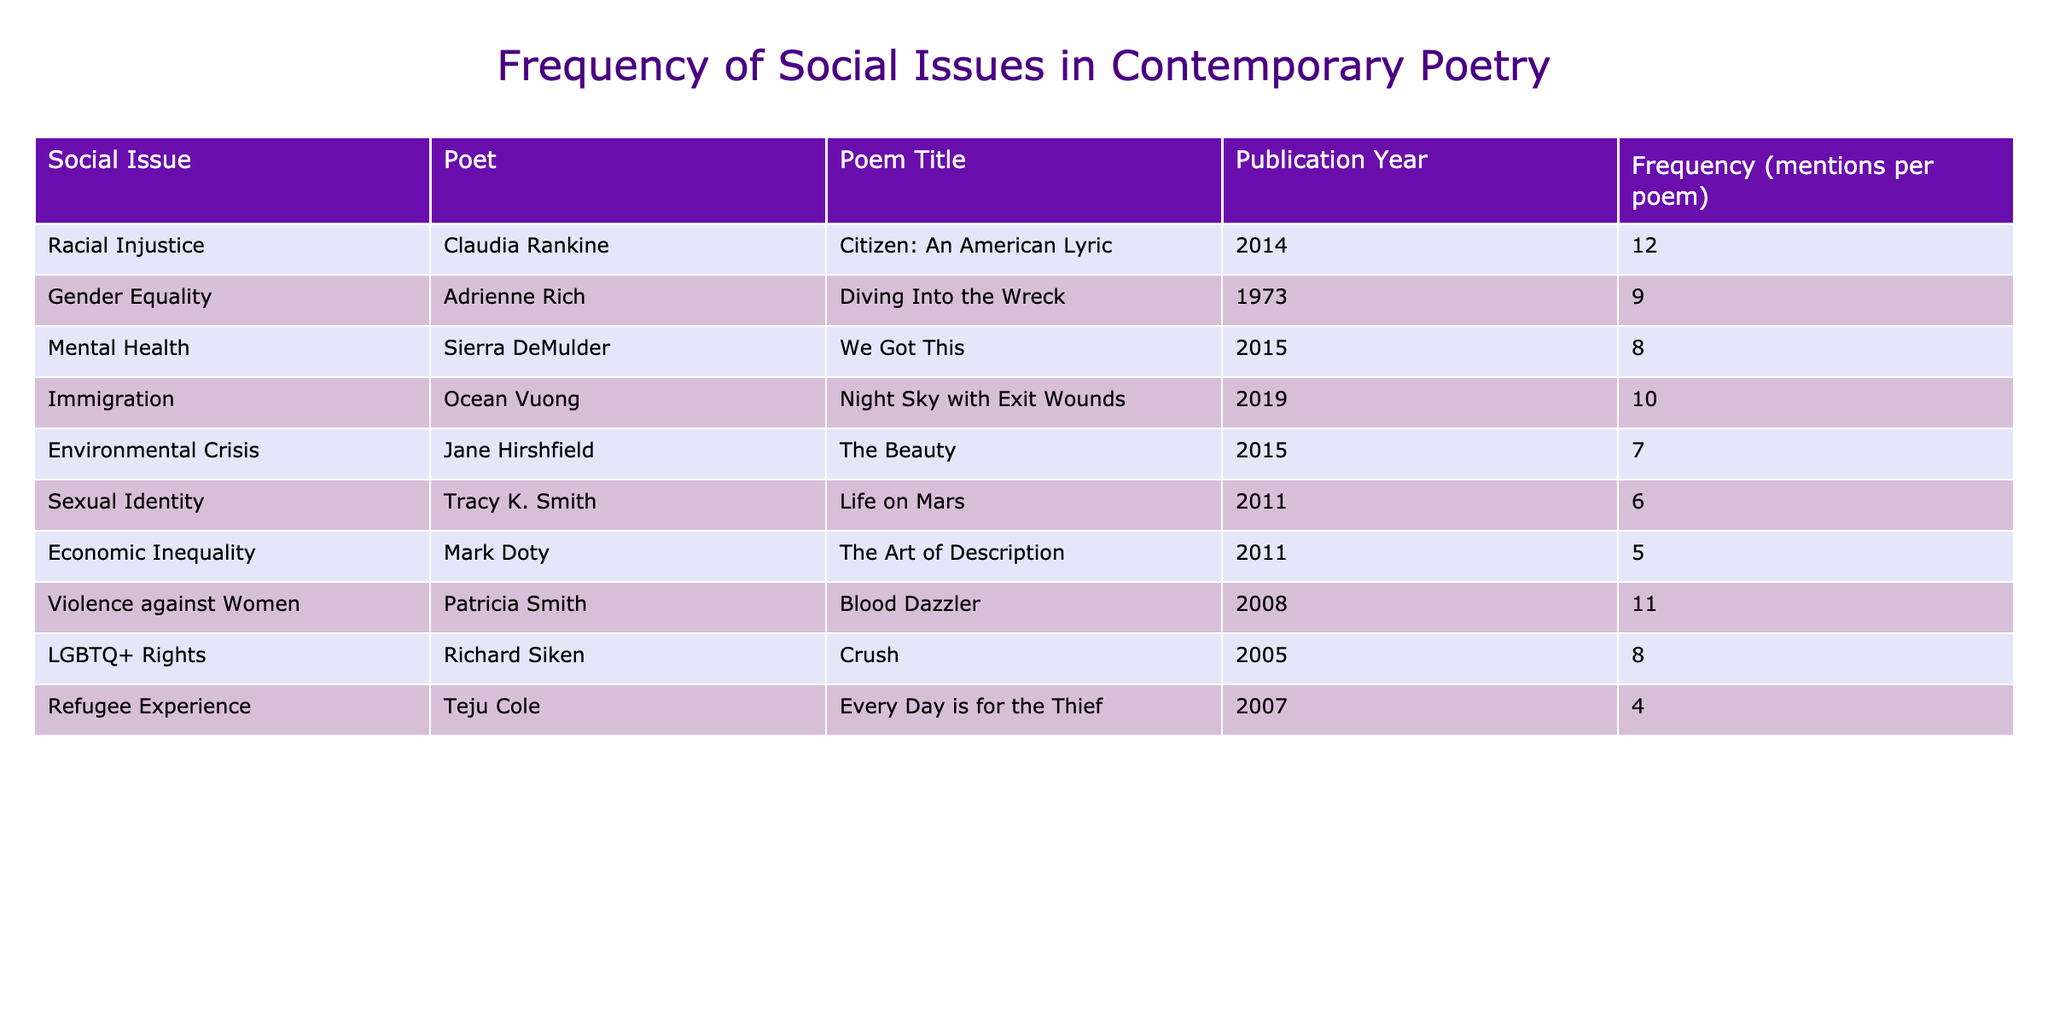What is the highest frequency of mentions for a social issue in the table? The highest frequency mentioned in the table is 12, associated with the social issue of Racial Injustice in Claudia Rankine's poem "Citizen: An American Lyric".
Answer: 12 Which poet addresses Gender Equality and what is the frequency of mentions in their poem? The poet addressing Gender Equality is Adrienne Rich, with a frequency of 9 mentions in the poem "Diving Into the Wreck".
Answer: 9 What is the average frequency of mentions for all social issues listed in the table? To find the average frequency, we first sum all the frequencies: 12 + 9 + 8 + 10 + 7 + 6 + 5 + 11 + 8 + 4 = 80. There are 10 data points, so the average frequency is 80/10 = 8.
Answer: 8 Does the poem "Blood Dazzler" address Racial Injustice? "Blood Dazzler" by Patricia Smith addresses Violence Against Women, not Racial Injustice, making the statement false.
Answer: No What is the difference in frequency of mentions between the social issues of Mental Health and Economic Inequality? Mental Health has a frequency of 8 mentions and Economic Inequality has a frequency of 5 mentions. The difference is 8 - 5 = 3.
Answer: 3 How many social issues have a frequency of mentions greater than 6? By examining the frequencies, the issues with more than 6 mentions are Racial Injustice (12), Gender Equality (9), Immigration (10), Mental Health (8), Violence Against Women (11), and LGBTQ+ Rights (8). Thus, there are 6 issues in total.
Answer: 6 Which social issue has the lowest frequency of mentions, and how many times is it mentioned? The social issue with the lowest frequency is the Refugee Experience, with 4 mentions in the poem "Every Day is for the Thief" by Teju Cole.
Answer: 4 Is it true that the poem "Crush" addresses Economic Inequality? "Crush" by Richard Siken addresses LGBTQ+ Rights and does not focus on Economic Inequality, so the statement is false.
Answer: No Which two social issues are addressed in the same year (2011) and what are their frequencies? The social issues addressed in the year 2011 are Sexual Identity (6 mentions) and Economic Inequality (5 mentions). Both are from the same year, highlighting a focus on social issues during that time.
Answer: 6 and 5 